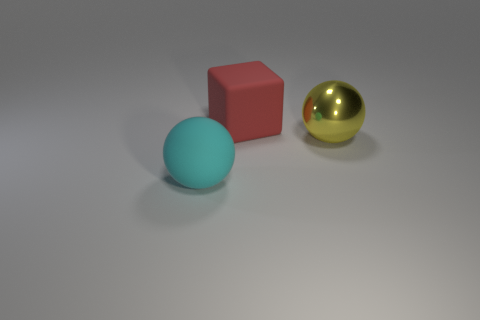There is a thing that is behind the metal ball; is its color the same as the matte sphere?
Provide a succinct answer. No. Does the matte object that is left of the red rubber thing have the same size as the yellow shiny thing?
Your answer should be compact. Yes. Is there a matte object of the same color as the large matte cube?
Your answer should be very brief. No. There is a large matte thing in front of the yellow metallic thing; is there a object in front of it?
Keep it short and to the point. No. Is there a large yellow object made of the same material as the big yellow sphere?
Your answer should be very brief. No. What material is the big object left of the rubber object that is behind the yellow thing?
Provide a succinct answer. Rubber. There is a big thing that is both in front of the large red cube and left of the yellow thing; what material is it?
Make the answer very short. Rubber. Are there an equal number of metal balls that are behind the big matte block and matte balls?
Provide a short and direct response. No. How many cyan matte things have the same shape as the red thing?
Offer a very short reply. 0. What is the size of the rubber object on the right side of the object in front of the big object that is right of the big red block?
Your answer should be very brief. Large. 